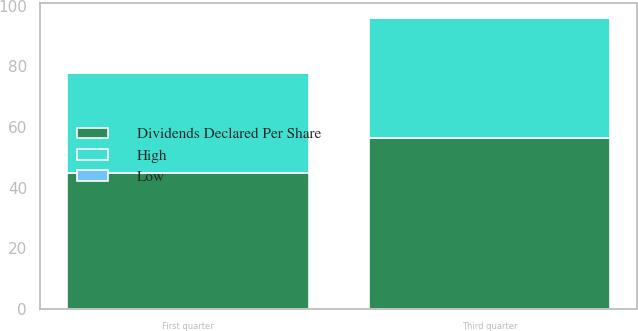Convert chart. <chart><loc_0><loc_0><loc_500><loc_500><stacked_bar_chart><ecel><fcel>Third quarter<fcel>First quarter<nl><fcel>Dividends Declared Per Share<fcel>56.35<fcel>44.82<nl><fcel>High<fcel>39.66<fcel>32.91<nl><fcel>Low<fcel>0.12<fcel>0.1<nl></chart> 